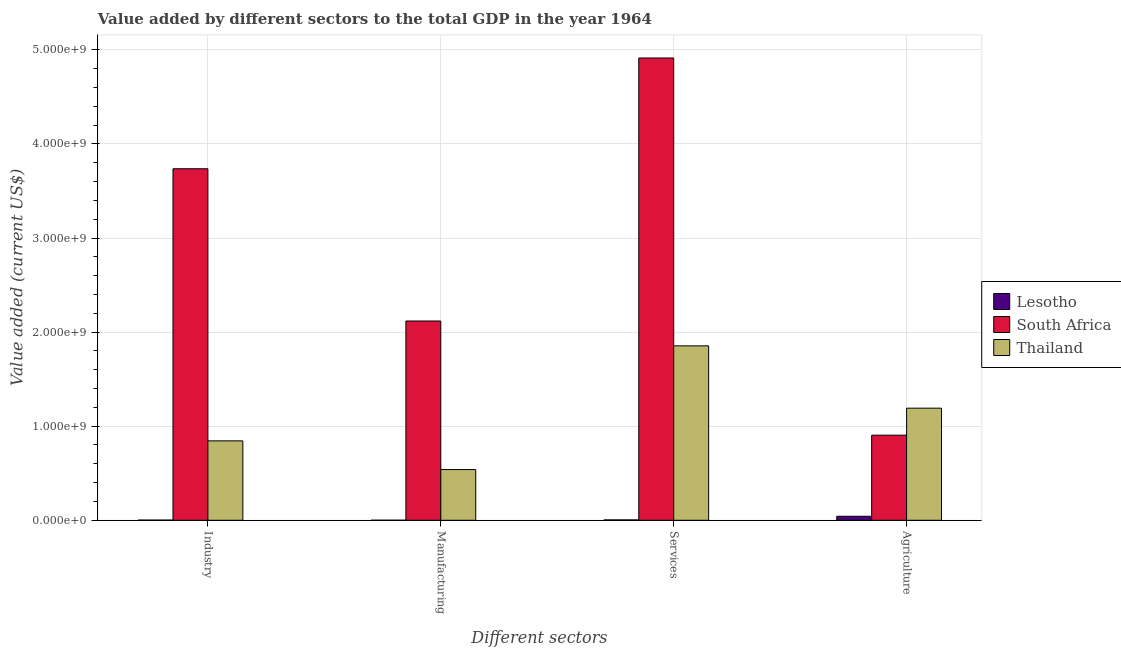How many groups of bars are there?
Your answer should be compact. 4. Are the number of bars per tick equal to the number of legend labels?
Give a very brief answer. Yes. What is the label of the 3rd group of bars from the left?
Ensure brevity in your answer.  Services. What is the value added by agricultural sector in South Africa?
Your answer should be very brief. 9.04e+08. Across all countries, what is the maximum value added by agricultural sector?
Keep it short and to the point. 1.19e+09. Across all countries, what is the minimum value added by industrial sector?
Provide a short and direct response. 1.91e+06. In which country was the value added by manufacturing sector maximum?
Offer a very short reply. South Africa. In which country was the value added by agricultural sector minimum?
Provide a succinct answer. Lesotho. What is the total value added by services sector in the graph?
Provide a succinct answer. 6.77e+09. What is the difference between the value added by manufacturing sector in Thailand and that in South Africa?
Provide a short and direct response. -1.58e+09. What is the difference between the value added by agricultural sector in Lesotho and the value added by industrial sector in South Africa?
Your response must be concise. -3.69e+09. What is the average value added by industrial sector per country?
Your response must be concise. 1.53e+09. What is the difference between the value added by agricultural sector and value added by services sector in Lesotho?
Provide a short and direct response. 3.88e+07. In how many countries, is the value added by services sector greater than 600000000 US$?
Provide a short and direct response. 2. What is the ratio of the value added by agricultural sector in Lesotho to that in South Africa?
Provide a succinct answer. 0.05. Is the value added by manufacturing sector in South Africa less than that in Lesotho?
Make the answer very short. No. Is the difference between the value added by industrial sector in Lesotho and South Africa greater than the difference between the value added by agricultural sector in Lesotho and South Africa?
Give a very brief answer. No. What is the difference between the highest and the second highest value added by manufacturing sector?
Offer a terse response. 1.58e+09. What is the difference between the highest and the lowest value added by industrial sector?
Keep it short and to the point. 3.73e+09. Is the sum of the value added by manufacturing sector in Lesotho and Thailand greater than the maximum value added by services sector across all countries?
Provide a short and direct response. No. Is it the case that in every country, the sum of the value added by industrial sector and value added by manufacturing sector is greater than the sum of value added by services sector and value added by agricultural sector?
Ensure brevity in your answer.  No. What does the 3rd bar from the left in Manufacturing represents?
Make the answer very short. Thailand. What does the 3rd bar from the right in Manufacturing represents?
Provide a short and direct response. Lesotho. Is it the case that in every country, the sum of the value added by industrial sector and value added by manufacturing sector is greater than the value added by services sector?
Offer a very short reply. No. Are all the bars in the graph horizontal?
Provide a succinct answer. No. How many countries are there in the graph?
Your response must be concise. 3. Are the values on the major ticks of Y-axis written in scientific E-notation?
Your answer should be compact. Yes. Where does the legend appear in the graph?
Offer a terse response. Center right. What is the title of the graph?
Provide a succinct answer. Value added by different sectors to the total GDP in the year 1964. Does "Tajikistan" appear as one of the legend labels in the graph?
Give a very brief answer. No. What is the label or title of the X-axis?
Give a very brief answer. Different sectors. What is the label or title of the Y-axis?
Ensure brevity in your answer.  Value added (current US$). What is the Value added (current US$) in Lesotho in Industry?
Provide a succinct answer. 1.91e+06. What is the Value added (current US$) of South Africa in Industry?
Give a very brief answer. 3.74e+09. What is the Value added (current US$) in Thailand in Industry?
Offer a terse response. 8.44e+08. What is the Value added (current US$) of Lesotho in Manufacturing?
Make the answer very short. 4.20e+05. What is the Value added (current US$) in South Africa in Manufacturing?
Your answer should be very brief. 2.12e+09. What is the Value added (current US$) in Thailand in Manufacturing?
Your answer should be very brief. 5.39e+08. What is the Value added (current US$) of Lesotho in Services?
Offer a very short reply. 3.67e+06. What is the Value added (current US$) in South Africa in Services?
Offer a very short reply. 4.91e+09. What is the Value added (current US$) in Thailand in Services?
Give a very brief answer. 1.85e+09. What is the Value added (current US$) of Lesotho in Agriculture?
Ensure brevity in your answer.  4.24e+07. What is the Value added (current US$) in South Africa in Agriculture?
Offer a terse response. 9.04e+08. What is the Value added (current US$) in Thailand in Agriculture?
Give a very brief answer. 1.19e+09. Across all Different sectors, what is the maximum Value added (current US$) in Lesotho?
Give a very brief answer. 4.24e+07. Across all Different sectors, what is the maximum Value added (current US$) of South Africa?
Your response must be concise. 4.91e+09. Across all Different sectors, what is the maximum Value added (current US$) of Thailand?
Provide a short and direct response. 1.85e+09. Across all Different sectors, what is the minimum Value added (current US$) in Lesotho?
Give a very brief answer. 4.20e+05. Across all Different sectors, what is the minimum Value added (current US$) in South Africa?
Provide a succinct answer. 9.04e+08. Across all Different sectors, what is the minimum Value added (current US$) in Thailand?
Give a very brief answer. 5.39e+08. What is the total Value added (current US$) of Lesotho in the graph?
Make the answer very short. 4.84e+07. What is the total Value added (current US$) in South Africa in the graph?
Make the answer very short. 1.17e+1. What is the total Value added (current US$) in Thailand in the graph?
Offer a very short reply. 4.43e+09. What is the difference between the Value added (current US$) in Lesotho in Industry and that in Manufacturing?
Offer a terse response. 1.49e+06. What is the difference between the Value added (current US$) of South Africa in Industry and that in Manufacturing?
Offer a very short reply. 1.62e+09. What is the difference between the Value added (current US$) of Thailand in Industry and that in Manufacturing?
Provide a short and direct response. 3.05e+08. What is the difference between the Value added (current US$) of Lesotho in Industry and that in Services?
Your answer should be very brief. -1.76e+06. What is the difference between the Value added (current US$) in South Africa in Industry and that in Services?
Keep it short and to the point. -1.18e+09. What is the difference between the Value added (current US$) in Thailand in Industry and that in Services?
Your response must be concise. -1.01e+09. What is the difference between the Value added (current US$) in Lesotho in Industry and that in Agriculture?
Make the answer very short. -4.05e+07. What is the difference between the Value added (current US$) of South Africa in Industry and that in Agriculture?
Provide a short and direct response. 2.83e+09. What is the difference between the Value added (current US$) of Thailand in Industry and that in Agriculture?
Your answer should be very brief. -3.47e+08. What is the difference between the Value added (current US$) in Lesotho in Manufacturing and that in Services?
Keep it short and to the point. -3.25e+06. What is the difference between the Value added (current US$) in South Africa in Manufacturing and that in Services?
Offer a terse response. -2.80e+09. What is the difference between the Value added (current US$) of Thailand in Manufacturing and that in Services?
Your response must be concise. -1.31e+09. What is the difference between the Value added (current US$) of Lesotho in Manufacturing and that in Agriculture?
Offer a terse response. -4.20e+07. What is the difference between the Value added (current US$) of South Africa in Manufacturing and that in Agriculture?
Make the answer very short. 1.21e+09. What is the difference between the Value added (current US$) in Thailand in Manufacturing and that in Agriculture?
Your answer should be compact. -6.52e+08. What is the difference between the Value added (current US$) in Lesotho in Services and that in Agriculture?
Keep it short and to the point. -3.88e+07. What is the difference between the Value added (current US$) in South Africa in Services and that in Agriculture?
Your response must be concise. 4.01e+09. What is the difference between the Value added (current US$) in Thailand in Services and that in Agriculture?
Offer a terse response. 6.62e+08. What is the difference between the Value added (current US$) in Lesotho in Industry and the Value added (current US$) in South Africa in Manufacturing?
Your answer should be very brief. -2.12e+09. What is the difference between the Value added (current US$) of Lesotho in Industry and the Value added (current US$) of Thailand in Manufacturing?
Give a very brief answer. -5.37e+08. What is the difference between the Value added (current US$) in South Africa in Industry and the Value added (current US$) in Thailand in Manufacturing?
Provide a succinct answer. 3.20e+09. What is the difference between the Value added (current US$) in Lesotho in Industry and the Value added (current US$) in South Africa in Services?
Offer a very short reply. -4.91e+09. What is the difference between the Value added (current US$) of Lesotho in Industry and the Value added (current US$) of Thailand in Services?
Keep it short and to the point. -1.85e+09. What is the difference between the Value added (current US$) in South Africa in Industry and the Value added (current US$) in Thailand in Services?
Your answer should be compact. 1.88e+09. What is the difference between the Value added (current US$) of Lesotho in Industry and the Value added (current US$) of South Africa in Agriculture?
Make the answer very short. -9.02e+08. What is the difference between the Value added (current US$) in Lesotho in Industry and the Value added (current US$) in Thailand in Agriculture?
Provide a succinct answer. -1.19e+09. What is the difference between the Value added (current US$) of South Africa in Industry and the Value added (current US$) of Thailand in Agriculture?
Your answer should be very brief. 2.54e+09. What is the difference between the Value added (current US$) in Lesotho in Manufacturing and the Value added (current US$) in South Africa in Services?
Give a very brief answer. -4.91e+09. What is the difference between the Value added (current US$) in Lesotho in Manufacturing and the Value added (current US$) in Thailand in Services?
Provide a short and direct response. -1.85e+09. What is the difference between the Value added (current US$) of South Africa in Manufacturing and the Value added (current US$) of Thailand in Services?
Your answer should be compact. 2.64e+08. What is the difference between the Value added (current US$) in Lesotho in Manufacturing and the Value added (current US$) in South Africa in Agriculture?
Ensure brevity in your answer.  -9.04e+08. What is the difference between the Value added (current US$) of Lesotho in Manufacturing and the Value added (current US$) of Thailand in Agriculture?
Make the answer very short. -1.19e+09. What is the difference between the Value added (current US$) of South Africa in Manufacturing and the Value added (current US$) of Thailand in Agriculture?
Your response must be concise. 9.27e+08. What is the difference between the Value added (current US$) of Lesotho in Services and the Value added (current US$) of South Africa in Agriculture?
Keep it short and to the point. -9.01e+08. What is the difference between the Value added (current US$) of Lesotho in Services and the Value added (current US$) of Thailand in Agriculture?
Give a very brief answer. -1.19e+09. What is the difference between the Value added (current US$) in South Africa in Services and the Value added (current US$) in Thailand in Agriculture?
Provide a succinct answer. 3.72e+09. What is the average Value added (current US$) of Lesotho per Different sectors?
Keep it short and to the point. 1.21e+07. What is the average Value added (current US$) of South Africa per Different sectors?
Provide a succinct answer. 2.92e+09. What is the average Value added (current US$) in Thailand per Different sectors?
Ensure brevity in your answer.  1.11e+09. What is the difference between the Value added (current US$) in Lesotho and Value added (current US$) in South Africa in Industry?
Offer a terse response. -3.73e+09. What is the difference between the Value added (current US$) in Lesotho and Value added (current US$) in Thailand in Industry?
Provide a short and direct response. -8.42e+08. What is the difference between the Value added (current US$) of South Africa and Value added (current US$) of Thailand in Industry?
Your response must be concise. 2.89e+09. What is the difference between the Value added (current US$) of Lesotho and Value added (current US$) of South Africa in Manufacturing?
Your response must be concise. -2.12e+09. What is the difference between the Value added (current US$) in Lesotho and Value added (current US$) in Thailand in Manufacturing?
Make the answer very short. -5.39e+08. What is the difference between the Value added (current US$) of South Africa and Value added (current US$) of Thailand in Manufacturing?
Offer a terse response. 1.58e+09. What is the difference between the Value added (current US$) in Lesotho and Value added (current US$) in South Africa in Services?
Ensure brevity in your answer.  -4.91e+09. What is the difference between the Value added (current US$) in Lesotho and Value added (current US$) in Thailand in Services?
Make the answer very short. -1.85e+09. What is the difference between the Value added (current US$) in South Africa and Value added (current US$) in Thailand in Services?
Provide a short and direct response. 3.06e+09. What is the difference between the Value added (current US$) in Lesotho and Value added (current US$) in South Africa in Agriculture?
Provide a succinct answer. -8.62e+08. What is the difference between the Value added (current US$) in Lesotho and Value added (current US$) in Thailand in Agriculture?
Your answer should be very brief. -1.15e+09. What is the difference between the Value added (current US$) of South Africa and Value added (current US$) of Thailand in Agriculture?
Provide a short and direct response. -2.87e+08. What is the ratio of the Value added (current US$) of Lesotho in Industry to that in Manufacturing?
Provide a succinct answer. 4.54. What is the ratio of the Value added (current US$) in South Africa in Industry to that in Manufacturing?
Offer a very short reply. 1.76. What is the ratio of the Value added (current US$) of Thailand in Industry to that in Manufacturing?
Your answer should be very brief. 1.57. What is the ratio of the Value added (current US$) of Lesotho in Industry to that in Services?
Your answer should be very brief. 0.52. What is the ratio of the Value added (current US$) of South Africa in Industry to that in Services?
Keep it short and to the point. 0.76. What is the ratio of the Value added (current US$) in Thailand in Industry to that in Services?
Make the answer very short. 0.46. What is the ratio of the Value added (current US$) in Lesotho in Industry to that in Agriculture?
Provide a short and direct response. 0.04. What is the ratio of the Value added (current US$) of South Africa in Industry to that in Agriculture?
Provide a short and direct response. 4.13. What is the ratio of the Value added (current US$) in Thailand in Industry to that in Agriculture?
Ensure brevity in your answer.  0.71. What is the ratio of the Value added (current US$) in Lesotho in Manufacturing to that in Services?
Offer a terse response. 0.11. What is the ratio of the Value added (current US$) of South Africa in Manufacturing to that in Services?
Provide a succinct answer. 0.43. What is the ratio of the Value added (current US$) of Thailand in Manufacturing to that in Services?
Provide a short and direct response. 0.29. What is the ratio of the Value added (current US$) in Lesotho in Manufacturing to that in Agriculture?
Your answer should be very brief. 0.01. What is the ratio of the Value added (current US$) of South Africa in Manufacturing to that in Agriculture?
Give a very brief answer. 2.34. What is the ratio of the Value added (current US$) in Thailand in Manufacturing to that in Agriculture?
Ensure brevity in your answer.  0.45. What is the ratio of the Value added (current US$) of Lesotho in Services to that in Agriculture?
Offer a very short reply. 0.09. What is the ratio of the Value added (current US$) in South Africa in Services to that in Agriculture?
Provide a short and direct response. 5.43. What is the ratio of the Value added (current US$) in Thailand in Services to that in Agriculture?
Provide a short and direct response. 1.56. What is the difference between the highest and the second highest Value added (current US$) of Lesotho?
Your response must be concise. 3.88e+07. What is the difference between the highest and the second highest Value added (current US$) in South Africa?
Give a very brief answer. 1.18e+09. What is the difference between the highest and the second highest Value added (current US$) of Thailand?
Offer a very short reply. 6.62e+08. What is the difference between the highest and the lowest Value added (current US$) in Lesotho?
Your response must be concise. 4.20e+07. What is the difference between the highest and the lowest Value added (current US$) in South Africa?
Offer a terse response. 4.01e+09. What is the difference between the highest and the lowest Value added (current US$) in Thailand?
Make the answer very short. 1.31e+09. 